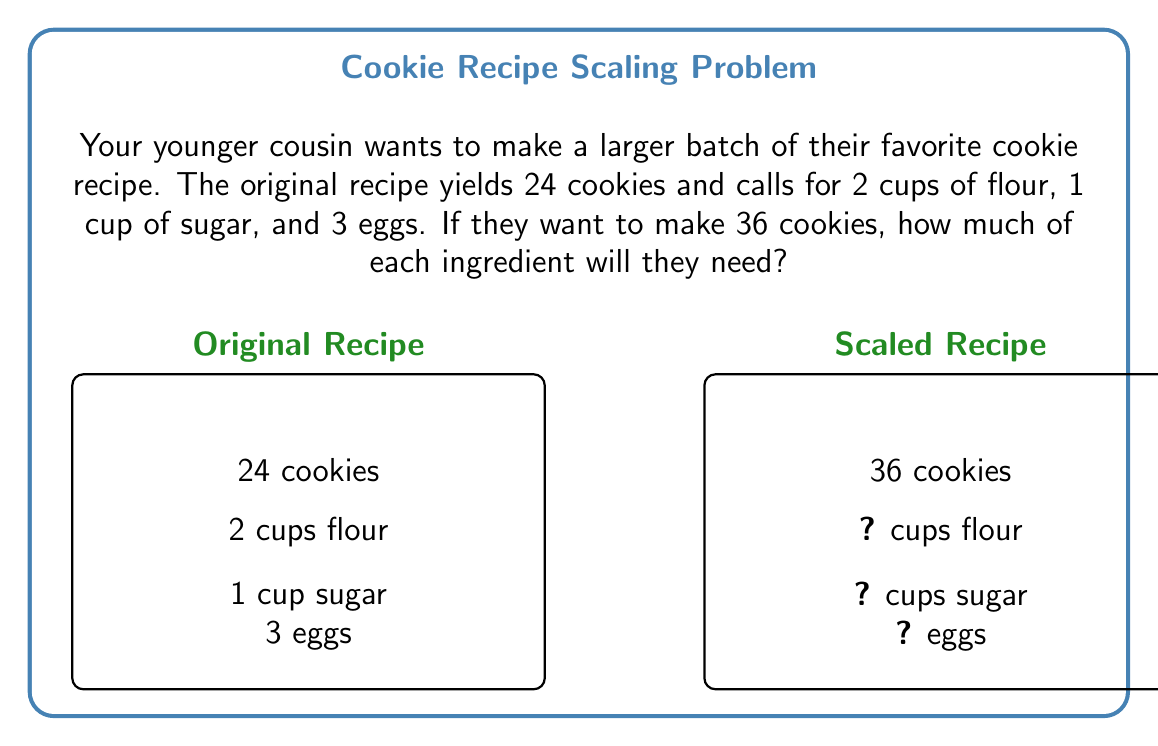Solve this math problem. To scale a recipe, we need to determine the proportion between the desired yield and the original yield, then apply this proportion to each ingredient. Let's solve this step-by-step:

1) Calculate the scaling factor:
   $\text{Scaling factor} = \frac{\text{Desired yield}}{\text{Original yield}} = \frac{36 \text{ cookies}}{24 \text{ cookies}} = 1.5$

2) Apply the scaling factor to each ingredient:

   For flour:
   $2 \text{ cups} \times 1.5 = 3 \text{ cups}$

   For sugar:
   $1 \text{ cup} \times 1.5 = 1.5 \text{ cups}$

   For eggs:
   $3 \text{ eggs} \times 1.5 = 4.5 \text{ eggs}$

3) Round the number of eggs to the nearest whole number:
   4.5 eggs ≈ 5 eggs

Therefore, to make 36 cookies, your cousin will need:
- 3 cups of flour
- 1.5 cups of sugar
- 5 eggs
Answer: 3 cups flour, 1.5 cups sugar, 5 eggs 